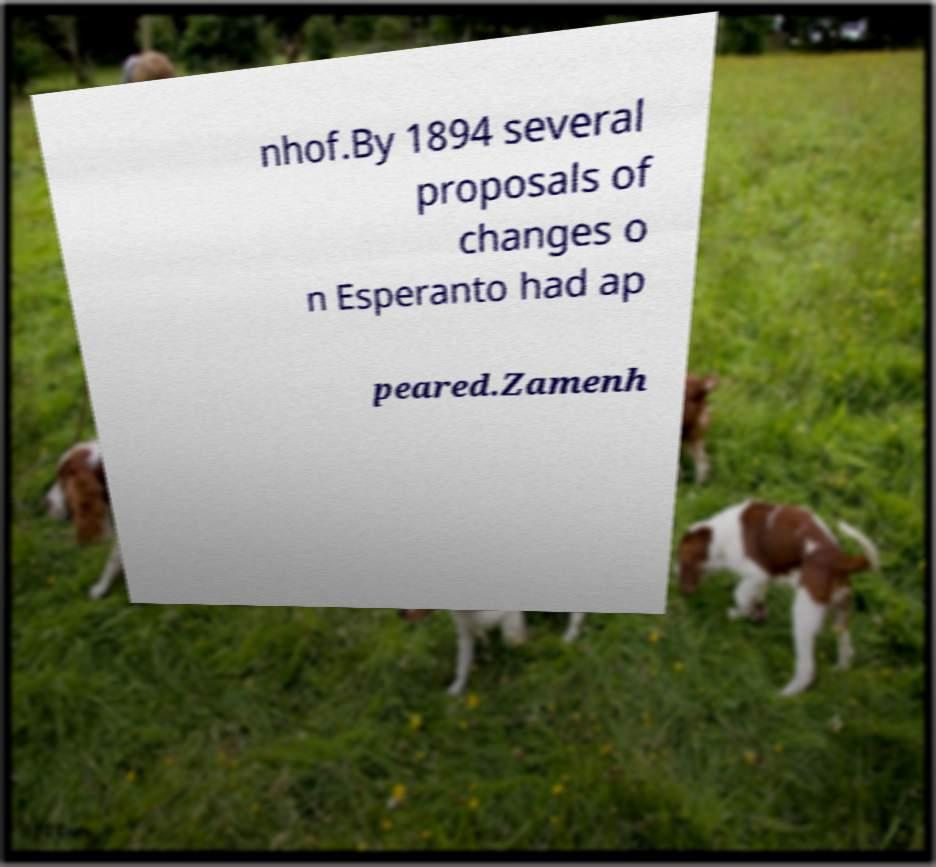What messages or text are displayed in this image? I need them in a readable, typed format. nhof.By 1894 several proposals of changes o n Esperanto had ap peared.Zamenh 